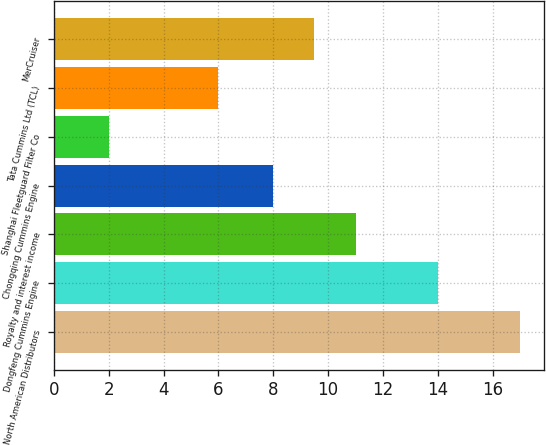<chart> <loc_0><loc_0><loc_500><loc_500><bar_chart><fcel>North American Distributors<fcel>Dongfeng Cummins Engine<fcel>Royalty and interest income<fcel>Chongqing Cummins Engine<fcel>Shanghai Fleetguard Filter Co<fcel>Tata Cummins Ltd (TCL)<fcel>MerCruiser<nl><fcel>17<fcel>14<fcel>11<fcel>8<fcel>2<fcel>6<fcel>9.5<nl></chart> 